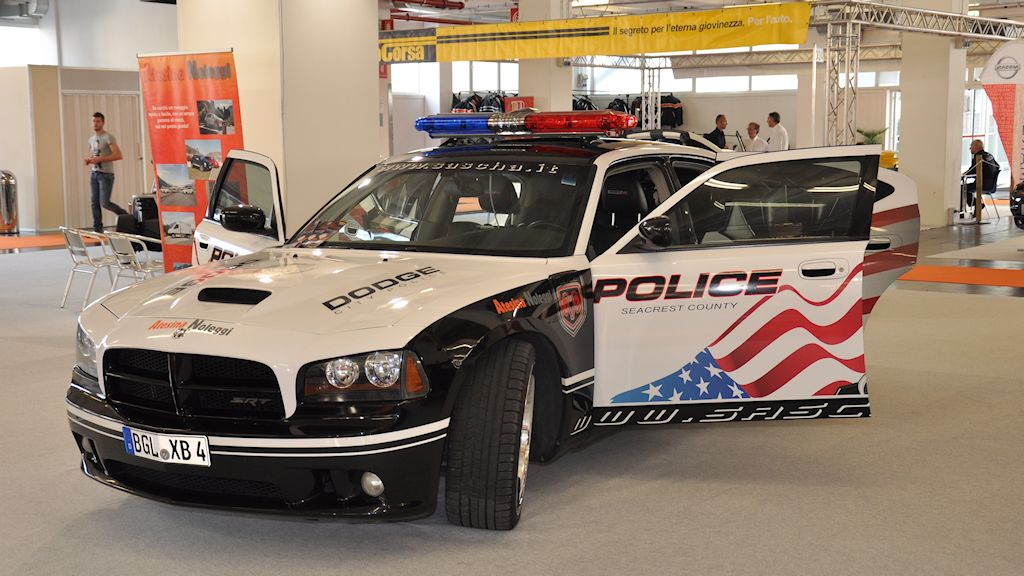Imagine this police car could transform into a robot. Describe its capabilities and how it would assist in law enforcement. If this police car could transform into a robot, it would stand tall, equipped with high-tech surveillance systems, powerful shielding, and an array of non-lethal enforcement tools like tasers and tranquilizer darts. Its legs would allow for rapid traversal of various terrains, and its arms would have extendable grips for rescue operations or apprehending suspects. The robot would feature advanced AI for crime analysis, instantly reviewing data to predict and prevent criminal activities. In a crisis, it could deploy drones for aerial support, providing real-time situiveillance. Its presence in the community would not only boost safety but also act as a cutting-edge deterrent against crime. 